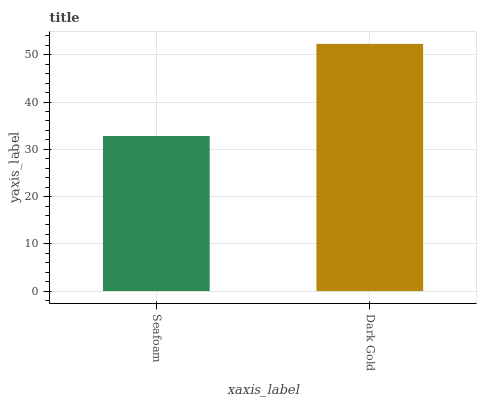Is Seafoam the minimum?
Answer yes or no. Yes. Is Dark Gold the maximum?
Answer yes or no. Yes. Is Dark Gold the minimum?
Answer yes or no. No. Is Dark Gold greater than Seafoam?
Answer yes or no. Yes. Is Seafoam less than Dark Gold?
Answer yes or no. Yes. Is Seafoam greater than Dark Gold?
Answer yes or no. No. Is Dark Gold less than Seafoam?
Answer yes or no. No. Is Dark Gold the high median?
Answer yes or no. Yes. Is Seafoam the low median?
Answer yes or no. Yes. Is Seafoam the high median?
Answer yes or no. No. Is Dark Gold the low median?
Answer yes or no. No. 